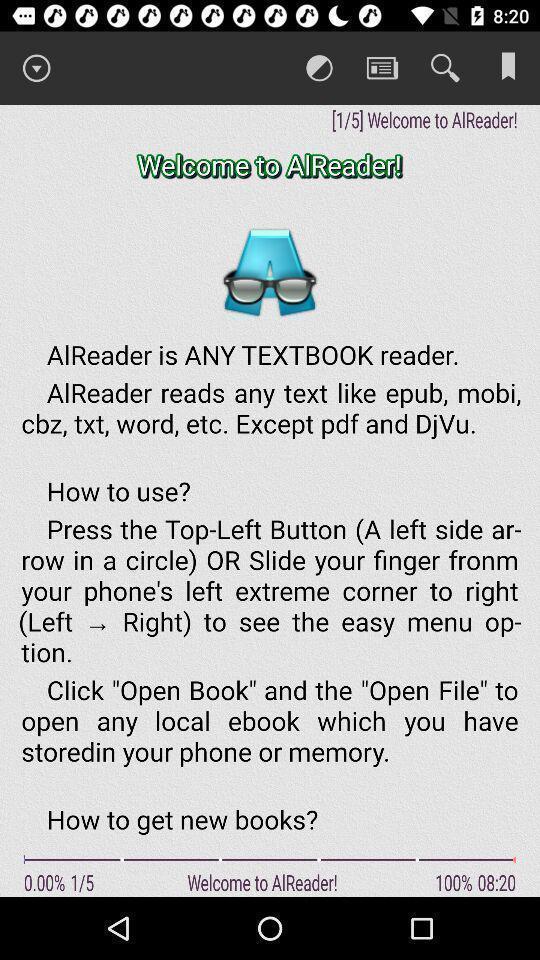Give me a summary of this screen capture. Welcome screen for a reading based app. 